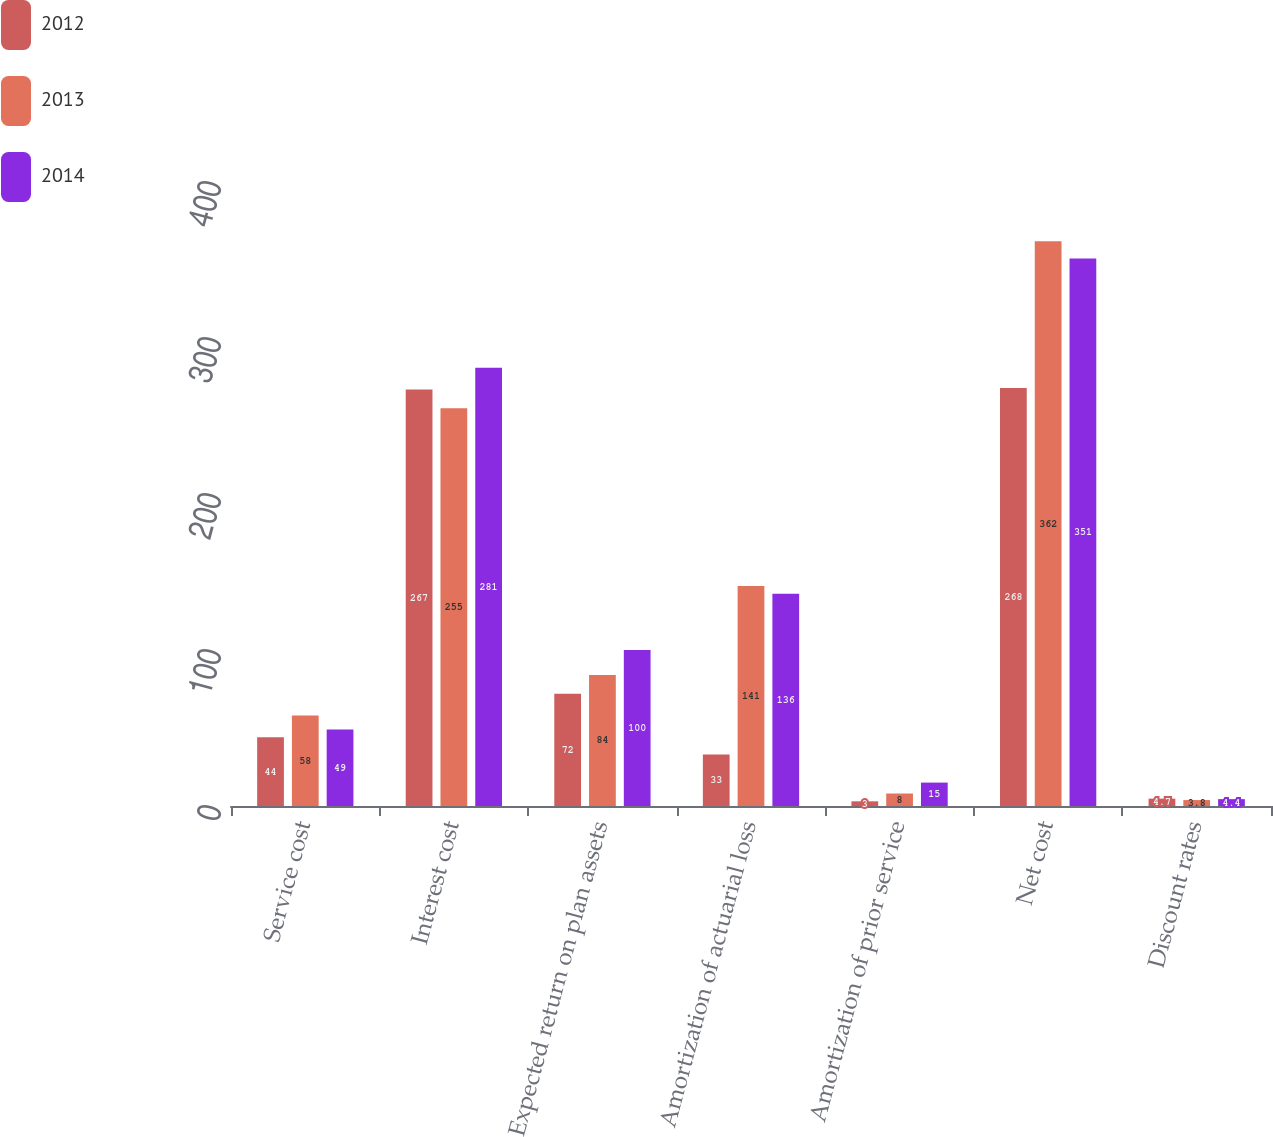<chart> <loc_0><loc_0><loc_500><loc_500><stacked_bar_chart><ecel><fcel>Service cost<fcel>Interest cost<fcel>Expected return on plan assets<fcel>Amortization of actuarial loss<fcel>Amortization of prior service<fcel>Net cost<fcel>Discount rates<nl><fcel>2012<fcel>44<fcel>267<fcel>72<fcel>33<fcel>3<fcel>268<fcel>4.7<nl><fcel>2013<fcel>58<fcel>255<fcel>84<fcel>141<fcel>8<fcel>362<fcel>3.8<nl><fcel>2014<fcel>49<fcel>281<fcel>100<fcel>136<fcel>15<fcel>351<fcel>4.4<nl></chart> 